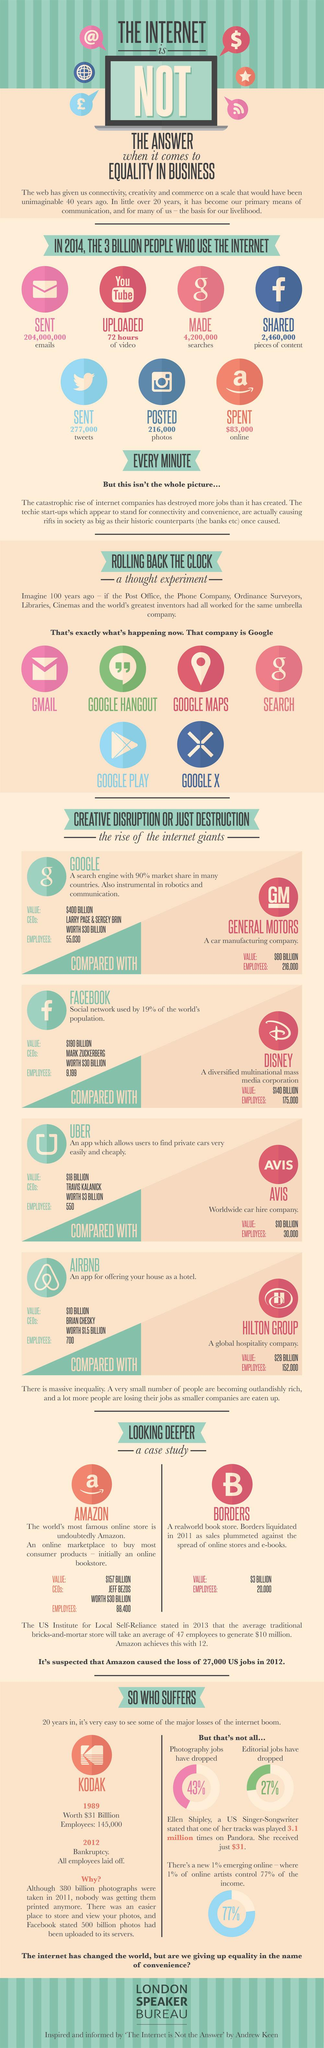Identify some key points in this picture. The app that was used to share photos on the internet was Instagram. According to the information provided, 2,460,000 pieces of content were shared on Facebook every minute. Google provides six services. 